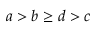<formula> <loc_0><loc_0><loc_500><loc_500>a > b \geq d > c</formula> 